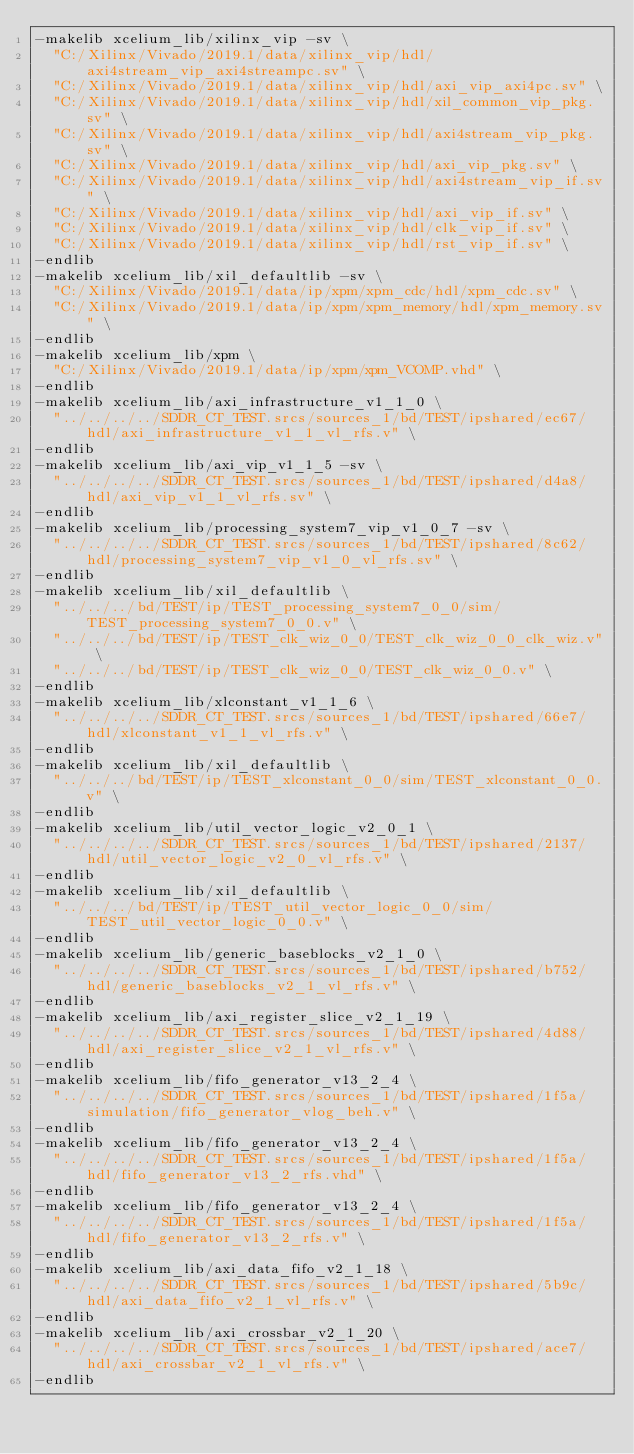<code> <loc_0><loc_0><loc_500><loc_500><_FORTRAN_>-makelib xcelium_lib/xilinx_vip -sv \
  "C:/Xilinx/Vivado/2019.1/data/xilinx_vip/hdl/axi4stream_vip_axi4streampc.sv" \
  "C:/Xilinx/Vivado/2019.1/data/xilinx_vip/hdl/axi_vip_axi4pc.sv" \
  "C:/Xilinx/Vivado/2019.1/data/xilinx_vip/hdl/xil_common_vip_pkg.sv" \
  "C:/Xilinx/Vivado/2019.1/data/xilinx_vip/hdl/axi4stream_vip_pkg.sv" \
  "C:/Xilinx/Vivado/2019.1/data/xilinx_vip/hdl/axi_vip_pkg.sv" \
  "C:/Xilinx/Vivado/2019.1/data/xilinx_vip/hdl/axi4stream_vip_if.sv" \
  "C:/Xilinx/Vivado/2019.1/data/xilinx_vip/hdl/axi_vip_if.sv" \
  "C:/Xilinx/Vivado/2019.1/data/xilinx_vip/hdl/clk_vip_if.sv" \
  "C:/Xilinx/Vivado/2019.1/data/xilinx_vip/hdl/rst_vip_if.sv" \
-endlib
-makelib xcelium_lib/xil_defaultlib -sv \
  "C:/Xilinx/Vivado/2019.1/data/ip/xpm/xpm_cdc/hdl/xpm_cdc.sv" \
  "C:/Xilinx/Vivado/2019.1/data/ip/xpm/xpm_memory/hdl/xpm_memory.sv" \
-endlib
-makelib xcelium_lib/xpm \
  "C:/Xilinx/Vivado/2019.1/data/ip/xpm/xpm_VCOMP.vhd" \
-endlib
-makelib xcelium_lib/axi_infrastructure_v1_1_0 \
  "../../../../SDDR_CT_TEST.srcs/sources_1/bd/TEST/ipshared/ec67/hdl/axi_infrastructure_v1_1_vl_rfs.v" \
-endlib
-makelib xcelium_lib/axi_vip_v1_1_5 -sv \
  "../../../../SDDR_CT_TEST.srcs/sources_1/bd/TEST/ipshared/d4a8/hdl/axi_vip_v1_1_vl_rfs.sv" \
-endlib
-makelib xcelium_lib/processing_system7_vip_v1_0_7 -sv \
  "../../../../SDDR_CT_TEST.srcs/sources_1/bd/TEST/ipshared/8c62/hdl/processing_system7_vip_v1_0_vl_rfs.sv" \
-endlib
-makelib xcelium_lib/xil_defaultlib \
  "../../../bd/TEST/ip/TEST_processing_system7_0_0/sim/TEST_processing_system7_0_0.v" \
  "../../../bd/TEST/ip/TEST_clk_wiz_0_0/TEST_clk_wiz_0_0_clk_wiz.v" \
  "../../../bd/TEST/ip/TEST_clk_wiz_0_0/TEST_clk_wiz_0_0.v" \
-endlib
-makelib xcelium_lib/xlconstant_v1_1_6 \
  "../../../../SDDR_CT_TEST.srcs/sources_1/bd/TEST/ipshared/66e7/hdl/xlconstant_v1_1_vl_rfs.v" \
-endlib
-makelib xcelium_lib/xil_defaultlib \
  "../../../bd/TEST/ip/TEST_xlconstant_0_0/sim/TEST_xlconstant_0_0.v" \
-endlib
-makelib xcelium_lib/util_vector_logic_v2_0_1 \
  "../../../../SDDR_CT_TEST.srcs/sources_1/bd/TEST/ipshared/2137/hdl/util_vector_logic_v2_0_vl_rfs.v" \
-endlib
-makelib xcelium_lib/xil_defaultlib \
  "../../../bd/TEST/ip/TEST_util_vector_logic_0_0/sim/TEST_util_vector_logic_0_0.v" \
-endlib
-makelib xcelium_lib/generic_baseblocks_v2_1_0 \
  "../../../../SDDR_CT_TEST.srcs/sources_1/bd/TEST/ipshared/b752/hdl/generic_baseblocks_v2_1_vl_rfs.v" \
-endlib
-makelib xcelium_lib/axi_register_slice_v2_1_19 \
  "../../../../SDDR_CT_TEST.srcs/sources_1/bd/TEST/ipshared/4d88/hdl/axi_register_slice_v2_1_vl_rfs.v" \
-endlib
-makelib xcelium_lib/fifo_generator_v13_2_4 \
  "../../../../SDDR_CT_TEST.srcs/sources_1/bd/TEST/ipshared/1f5a/simulation/fifo_generator_vlog_beh.v" \
-endlib
-makelib xcelium_lib/fifo_generator_v13_2_4 \
  "../../../../SDDR_CT_TEST.srcs/sources_1/bd/TEST/ipshared/1f5a/hdl/fifo_generator_v13_2_rfs.vhd" \
-endlib
-makelib xcelium_lib/fifo_generator_v13_2_4 \
  "../../../../SDDR_CT_TEST.srcs/sources_1/bd/TEST/ipshared/1f5a/hdl/fifo_generator_v13_2_rfs.v" \
-endlib
-makelib xcelium_lib/axi_data_fifo_v2_1_18 \
  "../../../../SDDR_CT_TEST.srcs/sources_1/bd/TEST/ipshared/5b9c/hdl/axi_data_fifo_v2_1_vl_rfs.v" \
-endlib
-makelib xcelium_lib/axi_crossbar_v2_1_20 \
  "../../../../SDDR_CT_TEST.srcs/sources_1/bd/TEST/ipshared/ace7/hdl/axi_crossbar_v2_1_vl_rfs.v" \
-endlib</code> 